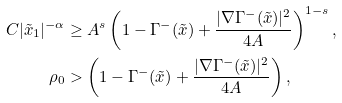<formula> <loc_0><loc_0><loc_500><loc_500>C | \tilde { x } _ { 1 } | ^ { - \alpha } & \geq A ^ { s } \left ( 1 - \Gamma ^ { - } ( \tilde { x } ) + \frac { | \nabla \Gamma ^ { - } ( \tilde { x } ) | ^ { 2 } } { 4 A } \right ) ^ { 1 - s } , \\ \rho _ { 0 } & > \left ( 1 - \Gamma ^ { - } ( \tilde { x } ) + \frac { | \nabla \Gamma ^ { - } ( \tilde { x } ) | ^ { 2 } } { 4 A } \right ) ,</formula> 